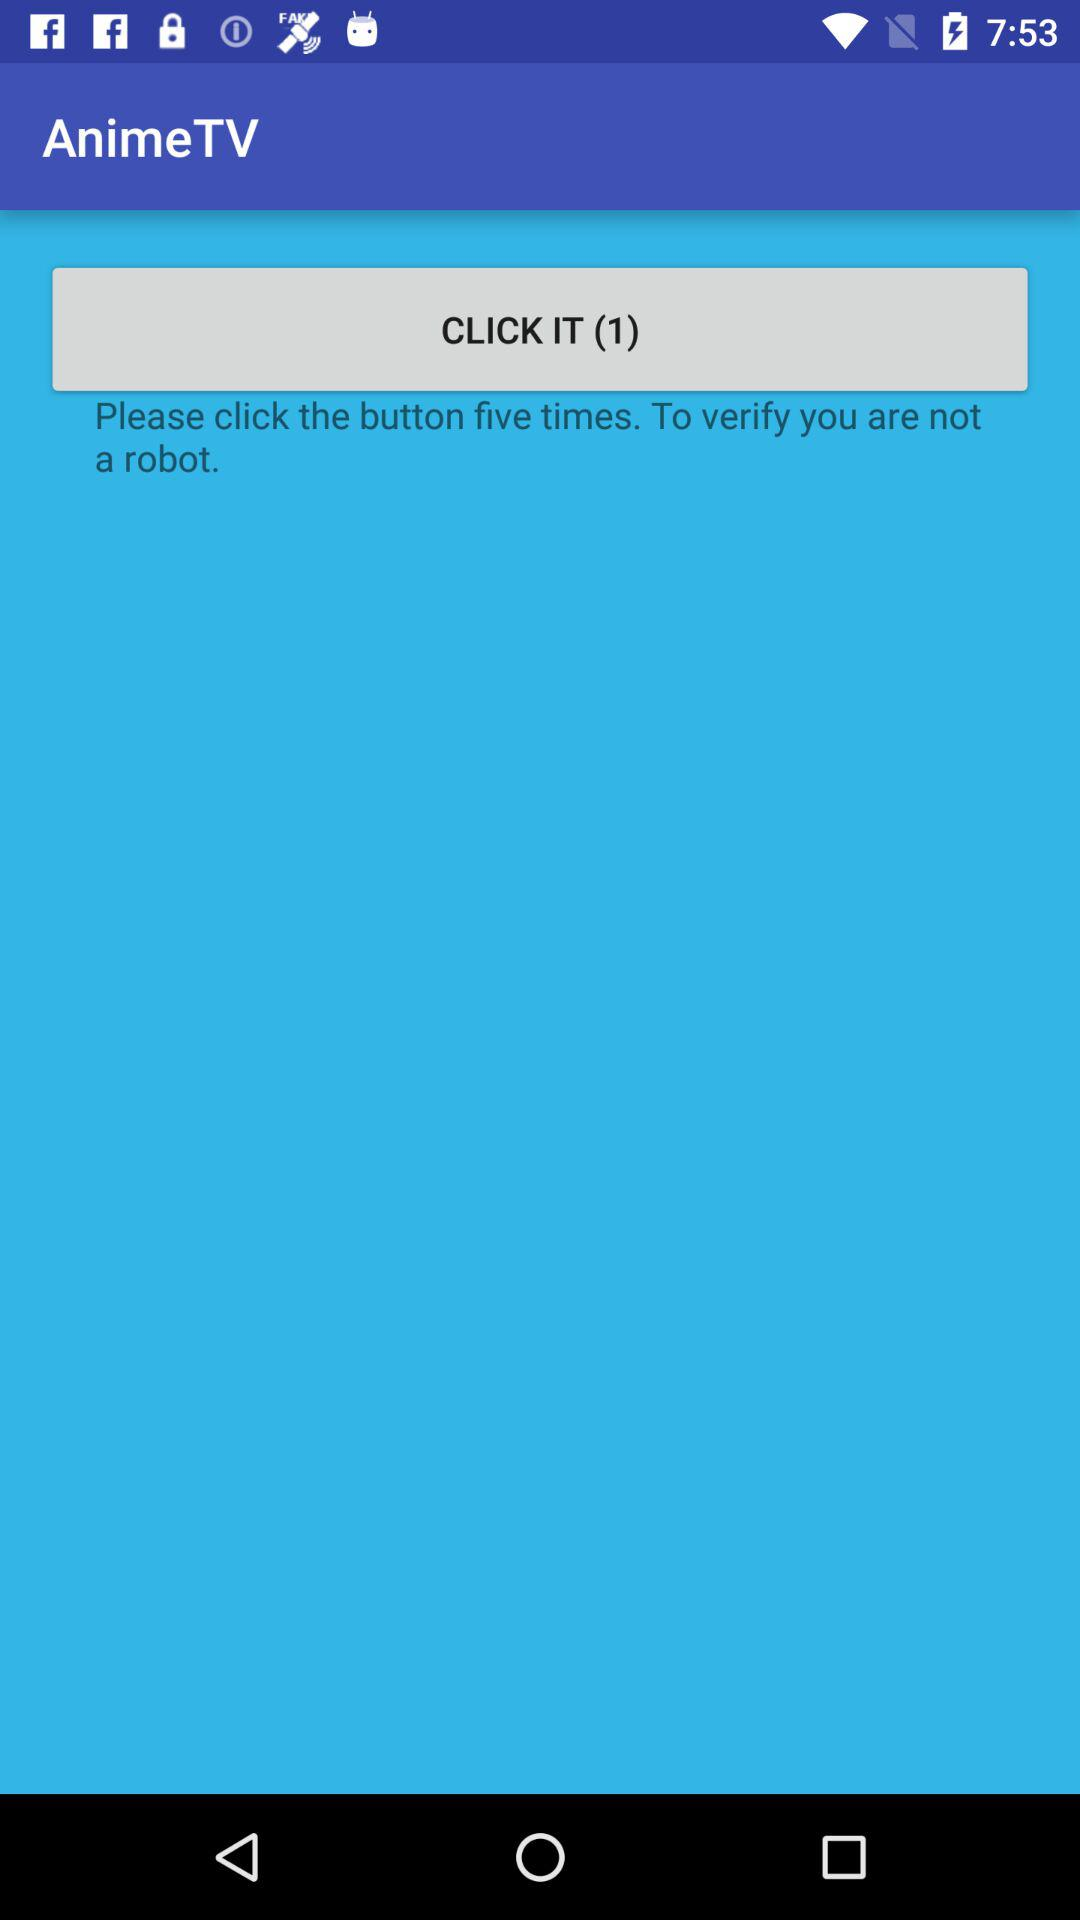Who is this application powered by?
When the provided information is insufficient, respond with <no answer>. <no answer> 